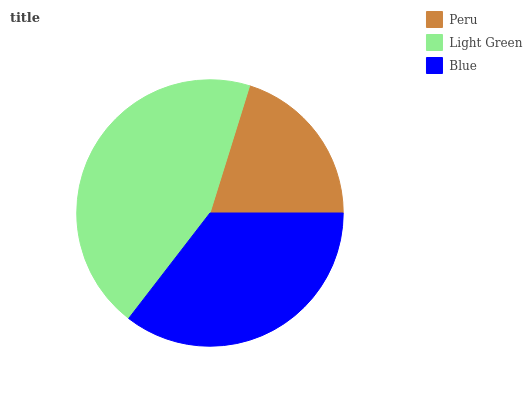Is Peru the minimum?
Answer yes or no. Yes. Is Light Green the maximum?
Answer yes or no. Yes. Is Blue the minimum?
Answer yes or no. No. Is Blue the maximum?
Answer yes or no. No. Is Light Green greater than Blue?
Answer yes or no. Yes. Is Blue less than Light Green?
Answer yes or no. Yes. Is Blue greater than Light Green?
Answer yes or no. No. Is Light Green less than Blue?
Answer yes or no. No. Is Blue the high median?
Answer yes or no. Yes. Is Blue the low median?
Answer yes or no. Yes. Is Light Green the high median?
Answer yes or no. No. Is Light Green the low median?
Answer yes or no. No. 